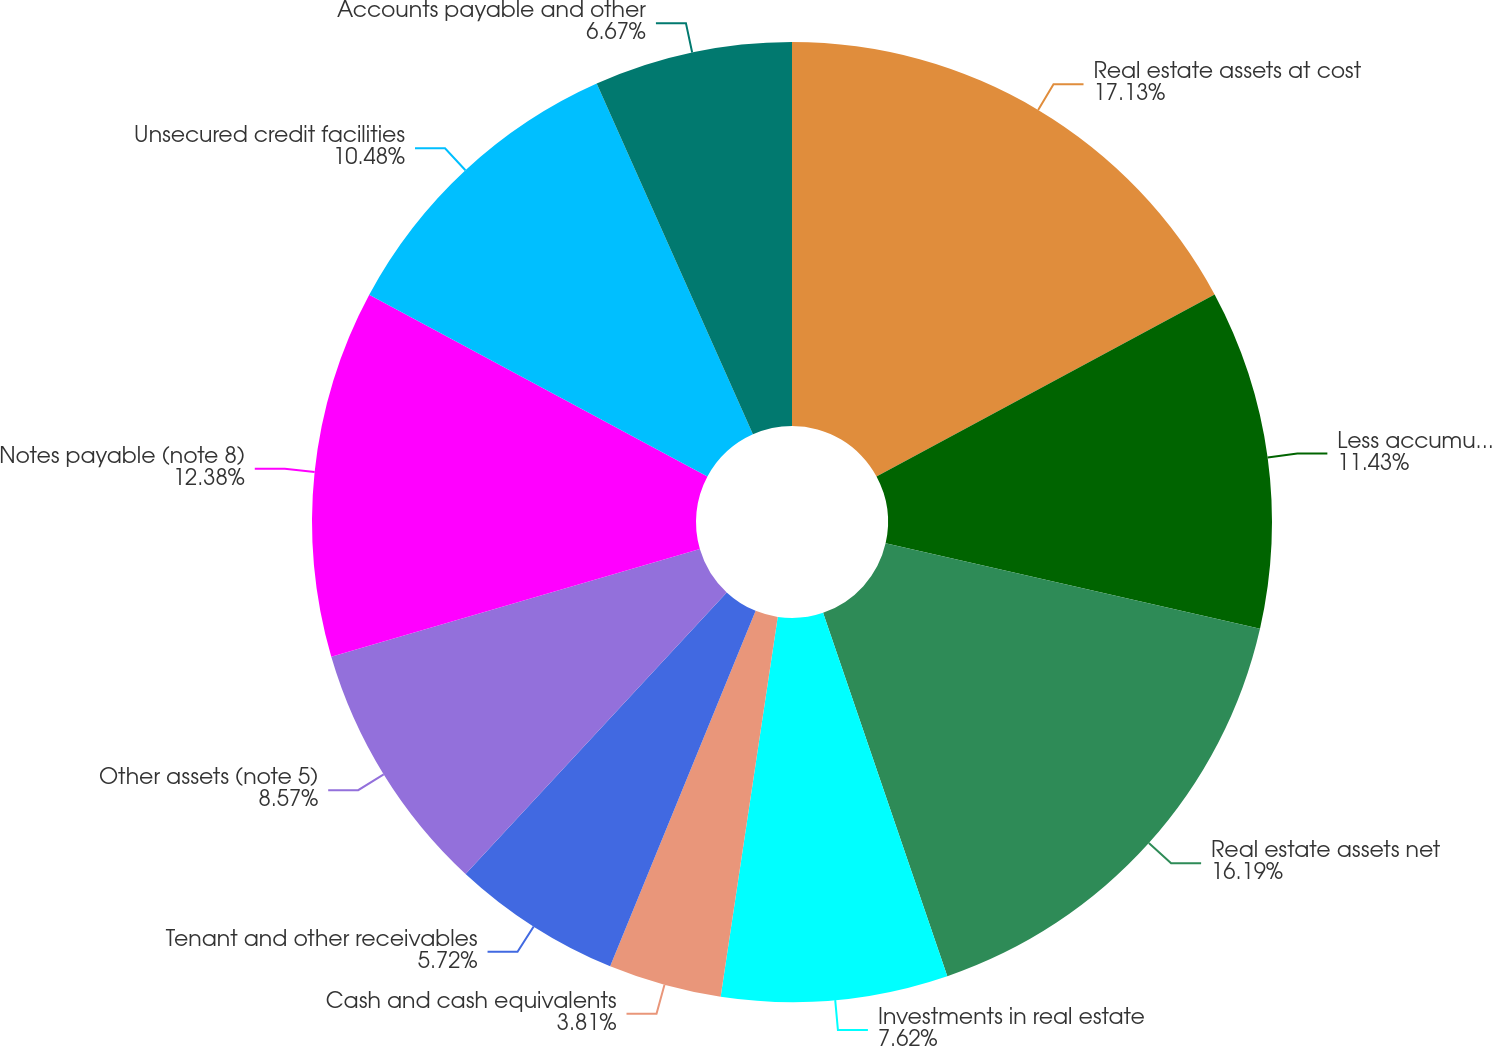Convert chart. <chart><loc_0><loc_0><loc_500><loc_500><pie_chart><fcel>Real estate assets at cost<fcel>Less accumulated depreciation<fcel>Real estate assets net<fcel>Investments in real estate<fcel>Cash and cash equivalents<fcel>Tenant and other receivables<fcel>Other assets (note 5)<fcel>Notes payable (note 8)<fcel>Unsecured credit facilities<fcel>Accounts payable and other<nl><fcel>17.14%<fcel>11.43%<fcel>16.19%<fcel>7.62%<fcel>3.81%<fcel>5.72%<fcel>8.57%<fcel>12.38%<fcel>10.48%<fcel>6.67%<nl></chart> 